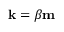Convert formula to latex. <formula><loc_0><loc_0><loc_500><loc_500>{ k } = \beta { m }</formula> 